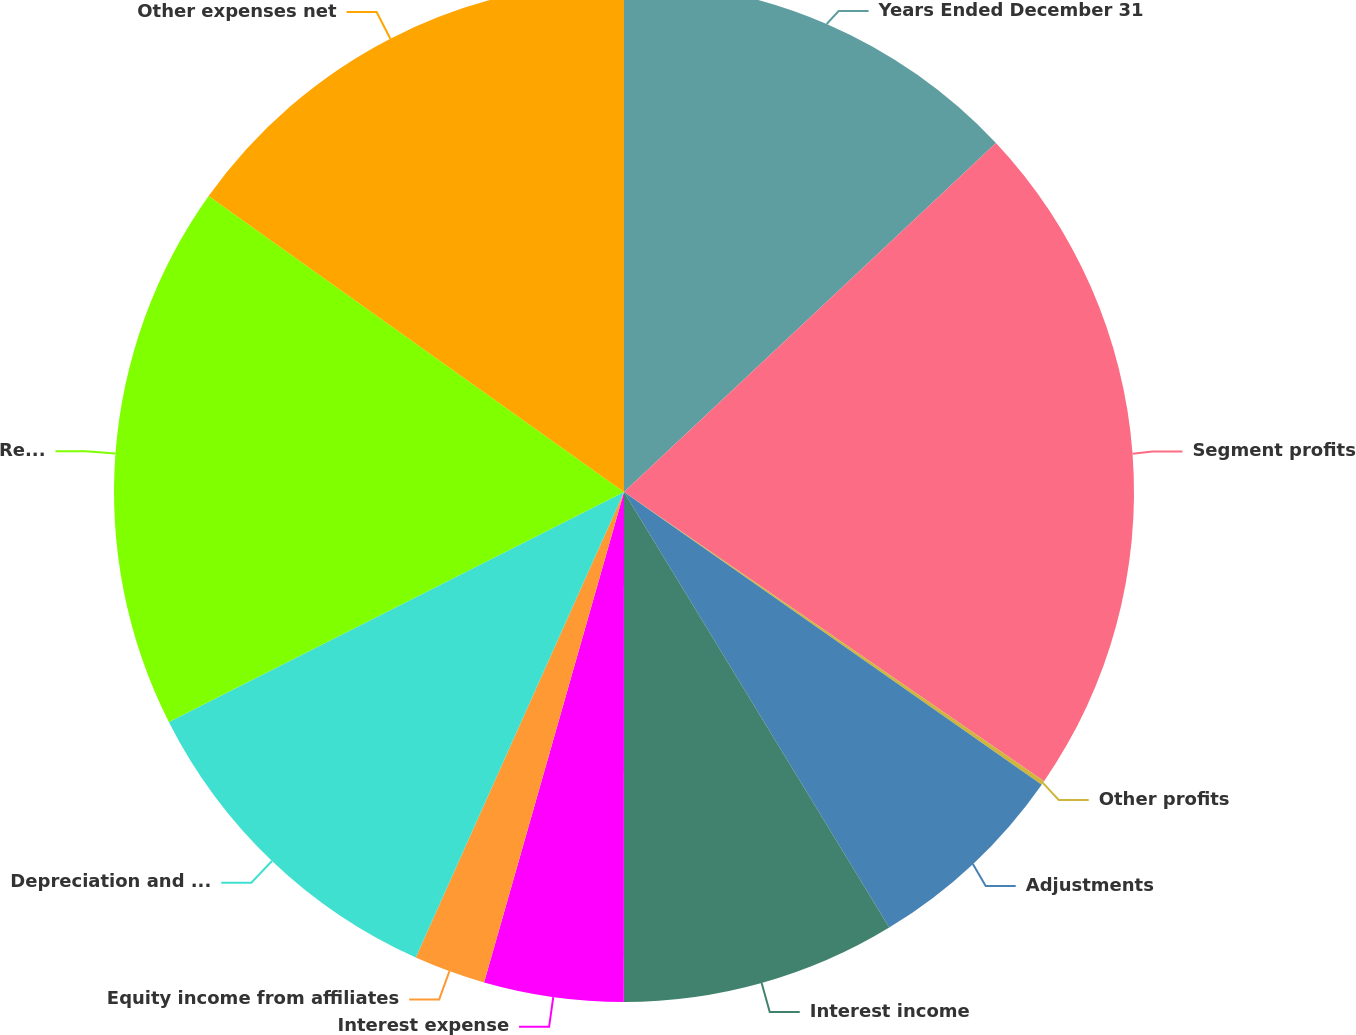<chart> <loc_0><loc_0><loc_500><loc_500><pie_chart><fcel>Years Ended December 31<fcel>Segment profits<fcel>Other profits<fcel>Adjustments<fcel>Interest income<fcel>Interest expense<fcel>Equity income from affiliates<fcel>Depreciation and amortization<fcel>Research and development<fcel>Other expenses net<nl><fcel>13.01%<fcel>21.59%<fcel>0.13%<fcel>6.57%<fcel>8.71%<fcel>4.42%<fcel>2.27%<fcel>10.86%<fcel>17.3%<fcel>15.15%<nl></chart> 